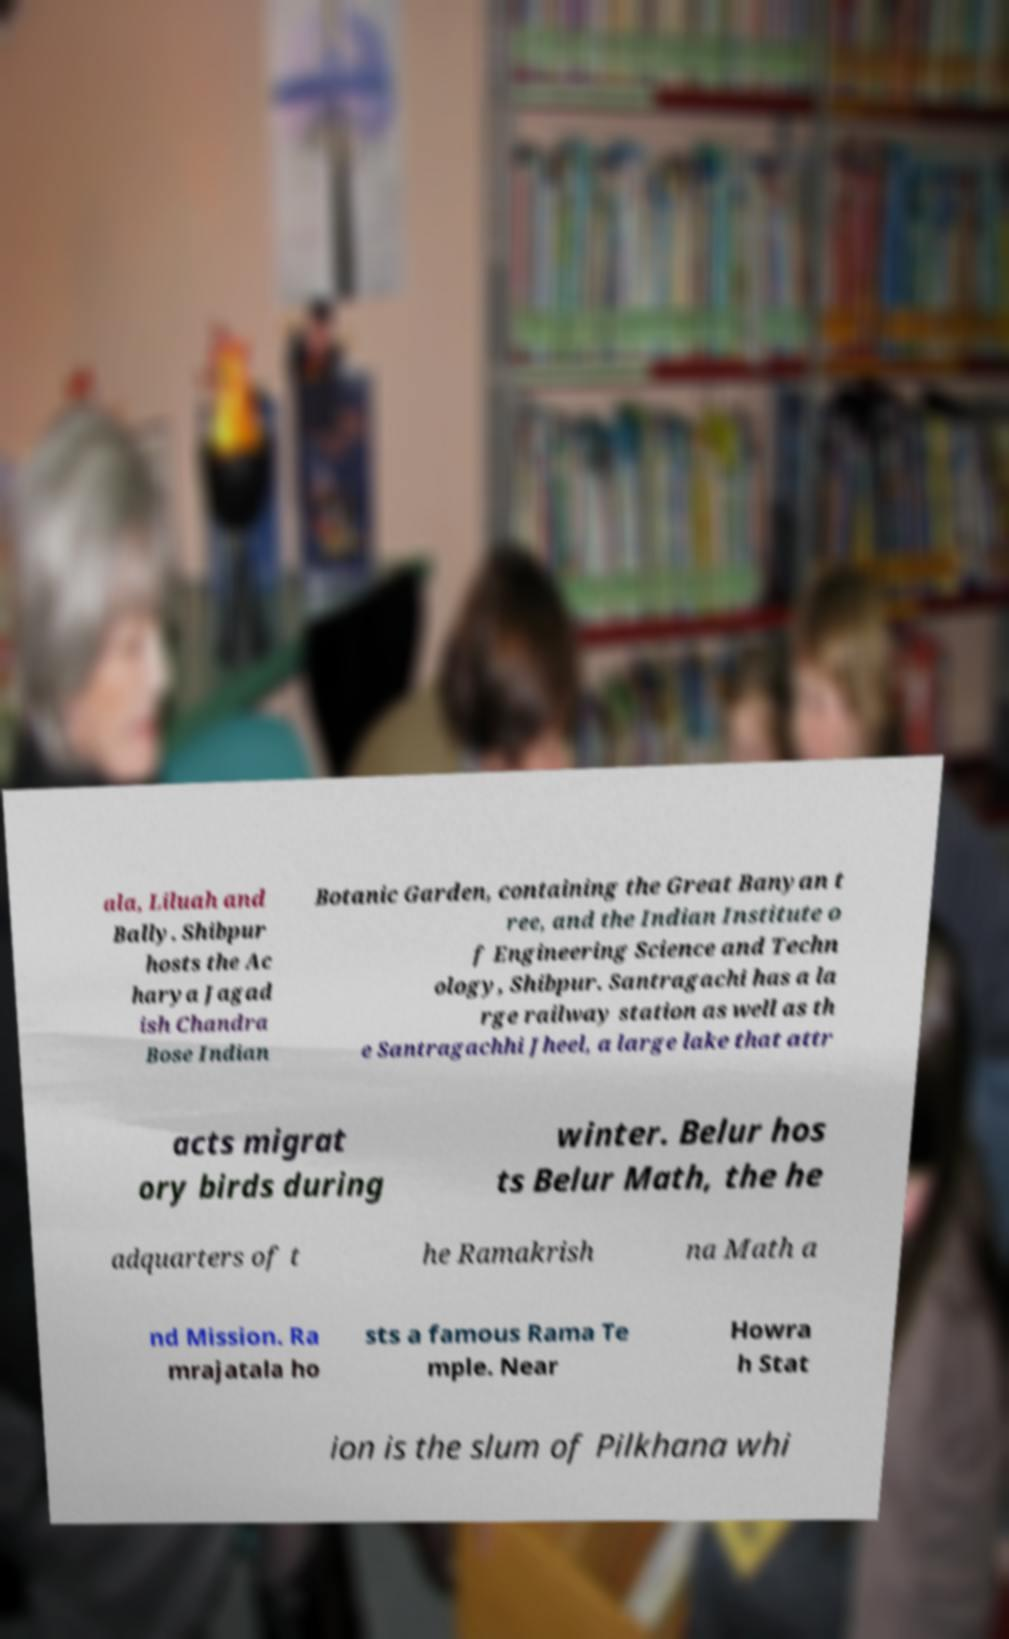Please identify and transcribe the text found in this image. ala, Liluah and Bally. Shibpur hosts the Ac harya Jagad ish Chandra Bose Indian Botanic Garden, containing the Great Banyan t ree, and the Indian Institute o f Engineering Science and Techn ology, Shibpur. Santragachi has a la rge railway station as well as th e Santragachhi Jheel, a large lake that attr acts migrat ory birds during winter. Belur hos ts Belur Math, the he adquarters of t he Ramakrish na Math a nd Mission. Ra mrajatala ho sts a famous Rama Te mple. Near Howra h Stat ion is the slum of Pilkhana whi 